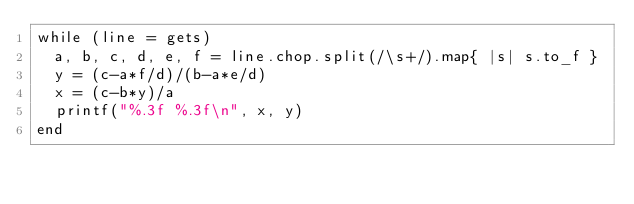Convert code to text. <code><loc_0><loc_0><loc_500><loc_500><_Ruby_>while (line = gets)
  a, b, c, d, e, f = line.chop.split(/\s+/).map{ |s| s.to_f }
  y = (c-a*f/d)/(b-a*e/d)
  x = (c-b*y)/a
  printf("%.3f %.3f\n", x, y)
end

</code> 